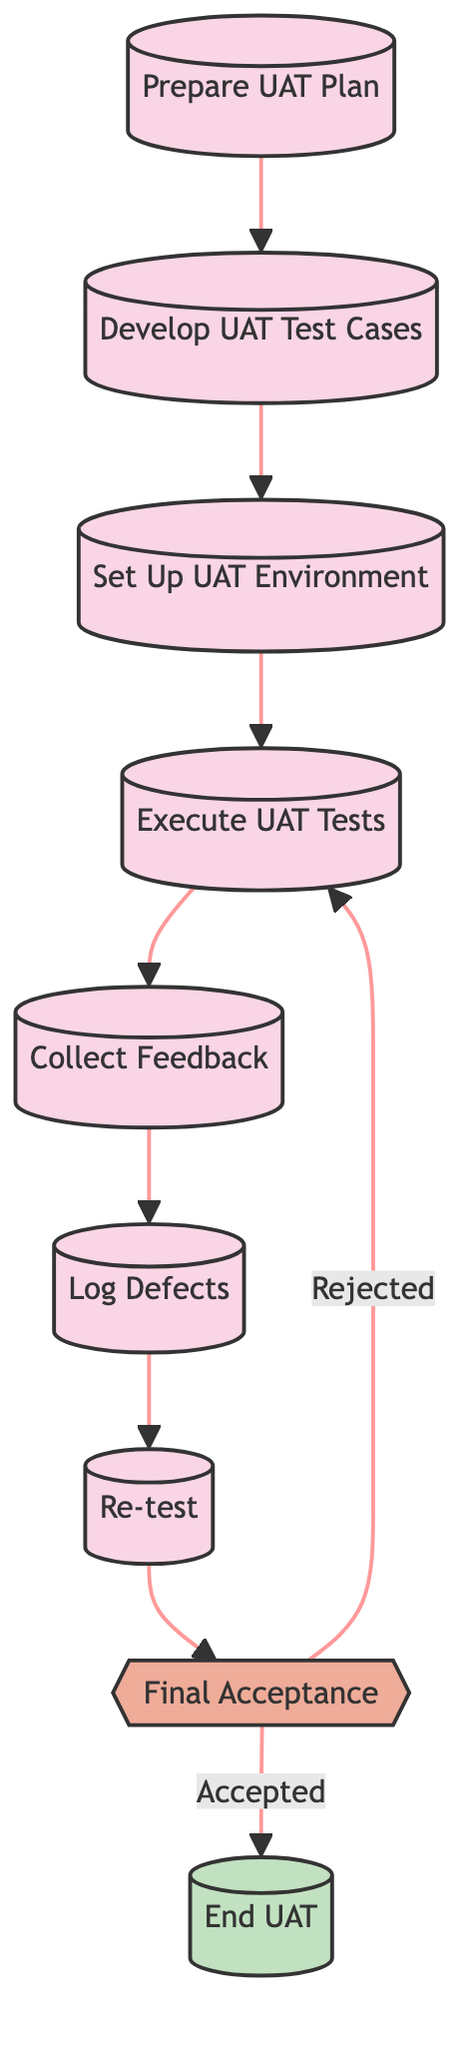What is the first step in the UAT process? The diagram shows that the first step is "Prepare UAT Plan" which is indicated by the first node in the flowchart.
Answer: Prepare UAT Plan How many total processes are there in the diagram? The diagram includes seven processes: Prepare UAT Plan, Develop UAT Test Cases, Set Up UAT Environment, Execute UAT Tests, Collect Feedback, Log Defects, and Re-test.
Answer: Seven What is the last decision point in the UAT process? The last decision point is "Final Acceptance," which is represented as a diamond shape in the flowchart before reaching the end node.
Answer: Final Acceptance Which step follows "Log Defects" in the process? According to the flowchart, after "Log Defects," the next step is "Re-test," which is a sequential flow depicted in the diagram.
Answer: Re-test If the outcome is accepted, what happens next? The diagram indicates that if the outcome is accepted at the "Final Acceptance" decision point, the flow leads to the node labeled "End UAT."
Answer: End UAT What type of node is "Final Acceptance"? "Final Acceptance" is classified as a decision node, which is represented by a diamond shape in the diagram, showing it is a point where a choice must be made.
Answer: Decision What action comes after "Collect Feedback"? The action that follows "Collect Feedback" in the flowchart is "Log Defects," indicating that feedback leads to the documentation of any issues found during testing.
Answer: Log Defects How many edges connect the processes in the flowchart? The diagram consists of six directed edges connecting the seven processes, indicating the flow from one process to the next.
Answer: Six 